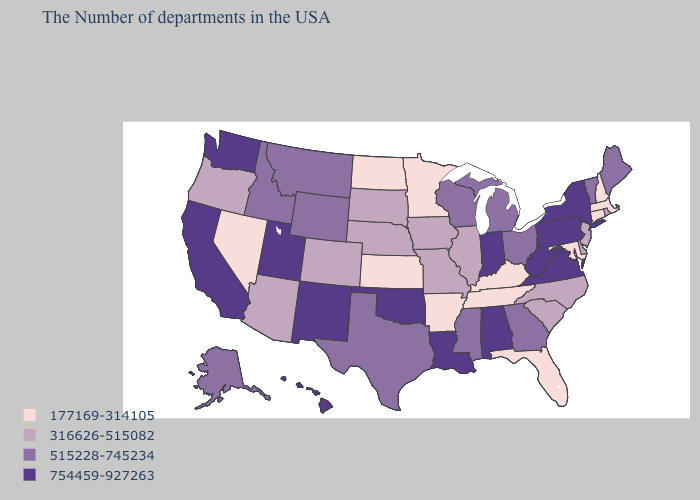Does New Mexico have the highest value in the USA?
Short answer required. Yes. Does Arkansas have the lowest value in the USA?
Keep it brief. Yes. Among the states that border South Dakota , which have the lowest value?
Concise answer only. Minnesota, North Dakota. What is the value of Louisiana?
Write a very short answer. 754459-927263. Is the legend a continuous bar?
Answer briefly. No. What is the value of Connecticut?
Keep it brief. 177169-314105. Which states have the lowest value in the West?
Keep it brief. Nevada. Name the states that have a value in the range 515228-745234?
Give a very brief answer. Maine, Vermont, Ohio, Georgia, Michigan, Wisconsin, Mississippi, Texas, Wyoming, Montana, Idaho, Alaska. What is the value of Virginia?
Quick response, please. 754459-927263. What is the value of Arkansas?
Concise answer only. 177169-314105. What is the lowest value in the MidWest?
Answer briefly. 177169-314105. What is the value of South Carolina?
Write a very short answer. 316626-515082. What is the lowest value in the USA?
Keep it brief. 177169-314105. Which states have the lowest value in the USA?
Write a very short answer. Massachusetts, New Hampshire, Connecticut, Maryland, Florida, Kentucky, Tennessee, Arkansas, Minnesota, Kansas, North Dakota, Nevada. Does New York have the highest value in the Northeast?
Keep it brief. Yes. 